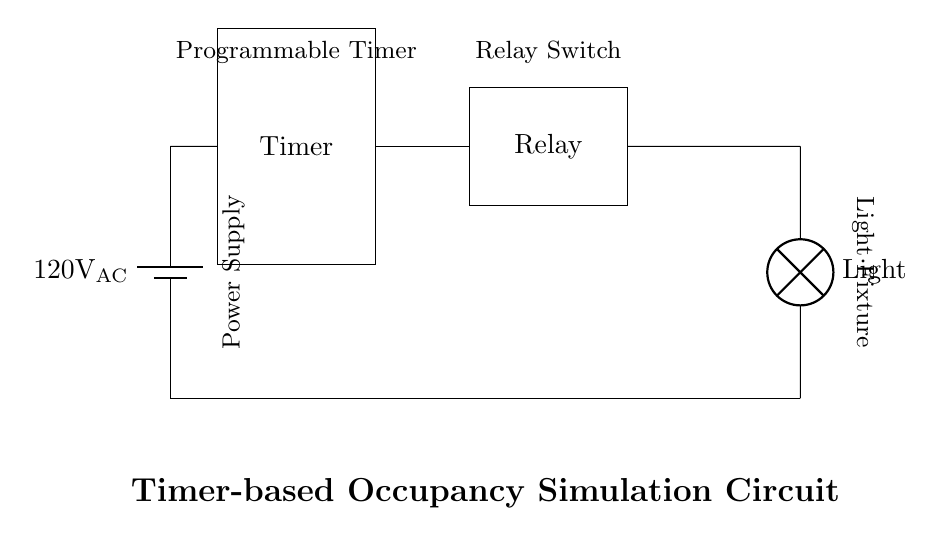What is the power supply voltage for this circuit? The power supply voltage is shown in the circuit diagram as 120V AC, which is labeled next to the battery symbol indicating the voltage level provided to the circuit.
Answer: 120V AC What component is responsible for controlling the light? The component responsible for controlling the light is the relay, which is depicted in the circuit diagram and is connected to the timer, allowing it to switch the light on or off based on the timer's settings.
Answer: Relay How many main components are there in this circuit? The circuit diagram shows three main components: the power supply, the timer, and the relay, along with the light bulb. Counting these components gives a total of three main elements involved in the operation.
Answer: Three What function does the timer serve in this circuit? The timer's function is to automatically control the on/off timing of the light, simulating occupancy by turning the light on and off at pre-set intervals while the occupants are away. This helps deter intruders by giving the appearance of a home being occupied.
Answer: Automate lighting What connects the timer to the relay in the circuit? The connection between the timer and the relay is shown with a line in the circuit diagram, which indicates an electrical connection that allows signals from the timer to control the relay's operation, thereby influencing the light's status.
Answer: Line What is the type of load being controlled by the relay? The load being controlled by the relay is a light bulb, as indicated in the diagram where the relay connects to the light fixture, allowing the relay to turn the light on or off based on the timer's commands.
Answer: Light bulb 